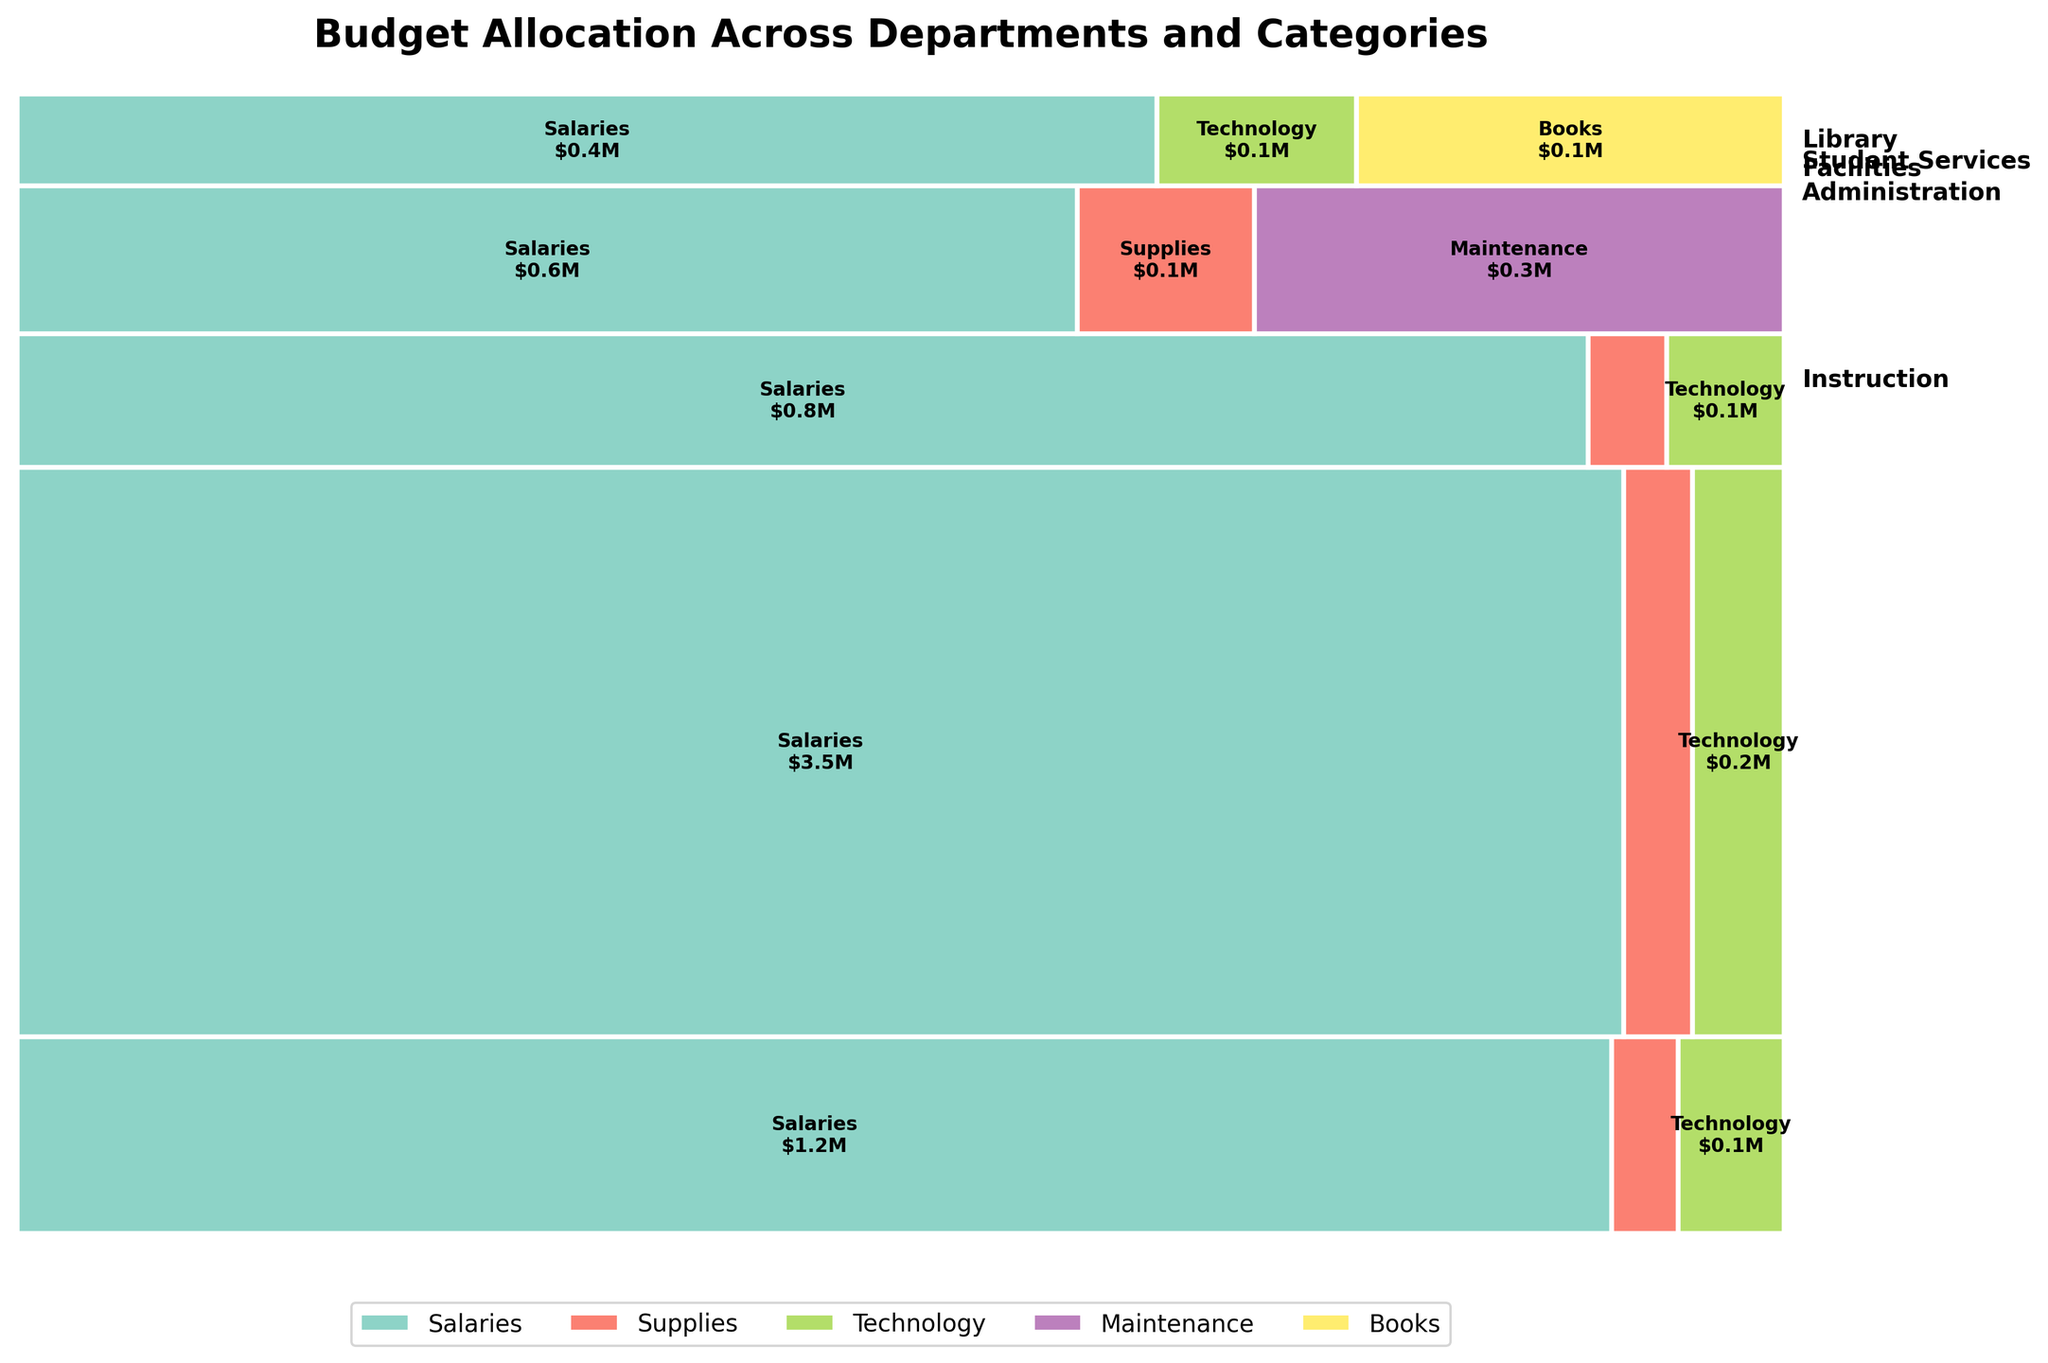What is the title of the figure? The title of the figure is usually placed at the top in a larger and bold font. In this case, it states the main topic or focus of the plot.
Answer: Budget Allocation Across Departments and Categories Which category has the highest budget allocation in the Administration department? Look at the rectangles corresponding to the Administration department and compare the widths of each category. The one with the largest width represents the highest budget allocation.
Answer: Salaries How are the categories distributed within the Instruction department? Identify the Instruction section in the plot. Within this section, observe the different proportions represented by the rectangles of each category. It shows percentages or relative sizes of salaries, supplies, and technology budgets.
Answer: Salaries take the major portion, followed by Technology and Supplies Which department has the smallest allocation for Technology? Compare the width of the Technology rectangle across all departments. The one with the narrowest rectangle indicates the smallest allocation.
Answer: Facilities How much is allocated to Supplies for each department? Refer to each department section in the plot and examine the rectangle labeled Supplies. Read the embedded text within these rectangles to determine the allocation amounts.
Answer: Administration: $0.05M, Instruction: $0.15M, Student Services: $0.04M, Facilities: $0.10M How does the total amount allocated to Technology compare between the Library and Student Services? Locate the Technology rectangles in both Library and Student Services sections. Compare their sizes and/or the figures written within them to determine the larger amount.
Answer: Library: $0.07M, Student Services: $0.06M Which department has the highest total budget allocation? Compare the total area covered by each department section, observing which section has the largest overall height. The one that takes up the most vertical space is the highest.
Answer: Instruction What is the amount allocated to Maintenance in Facilities? Look at the Facilities section and locate the rectangle labeled Maintenance. The figure written inside this rectangle indicates the allocated amount.
Answer: $0.3M What percentage of the total budget is allocated to Library? Calculate the height of the Library section relative to the entire height of the plot. This indicates the proportion of the budget allocated to Library.
Answer: ~5.4% Which category receives the highest budget allocation across all departments? Examine the entire plot and compare the total widths of rectangles for each category across all departments. The category with the largest cumulative width is the highest.
Answer: Salaries 